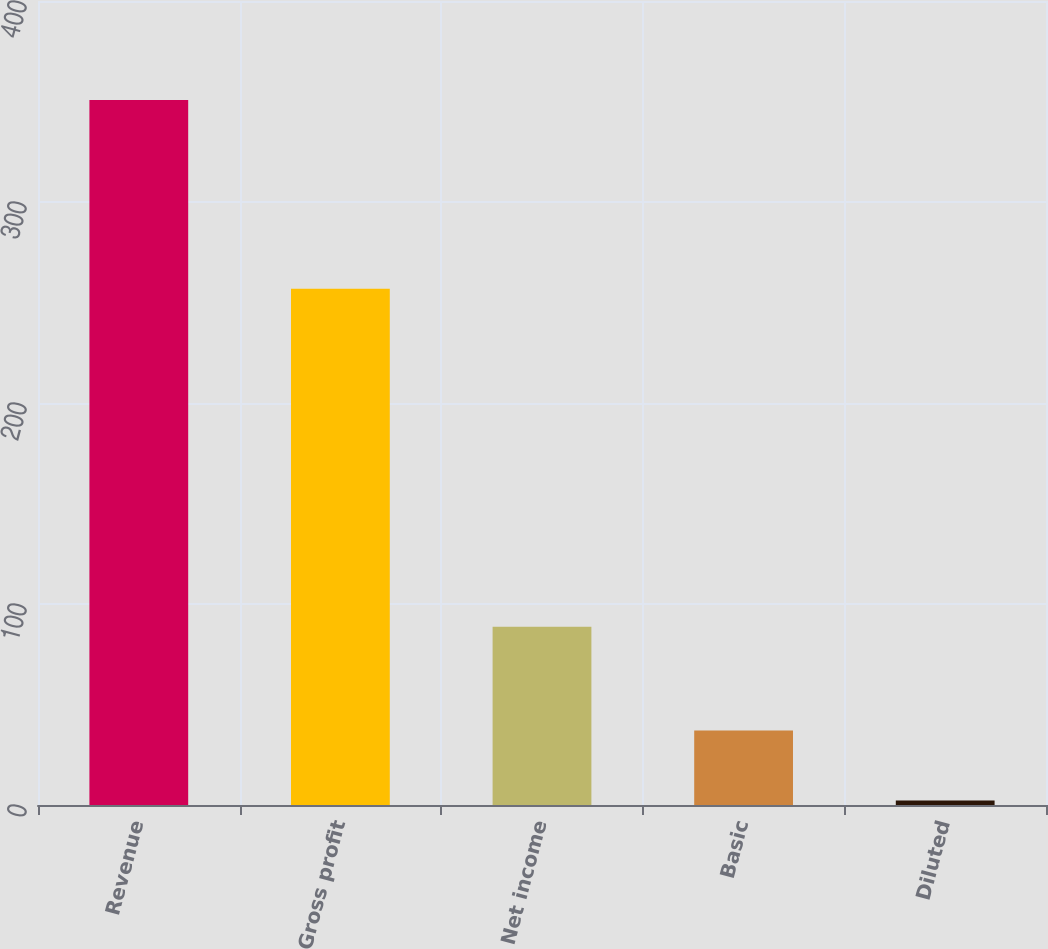<chart> <loc_0><loc_0><loc_500><loc_500><bar_chart><fcel>Revenue<fcel>Gross profit<fcel>Net income<fcel>Basic<fcel>Diluted<nl><fcel>350.7<fcel>256.8<fcel>88.7<fcel>37.04<fcel>2.19<nl></chart> 